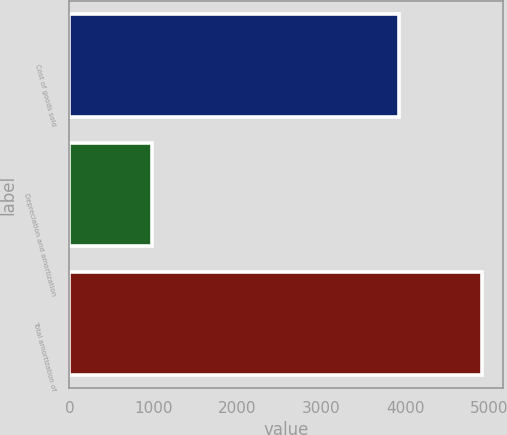Convert chart. <chart><loc_0><loc_0><loc_500><loc_500><bar_chart><fcel>Cost of goods sold<fcel>Depreciation and amortization<fcel>Total amortization of<nl><fcel>3927<fcel>983<fcel>4910<nl></chart> 